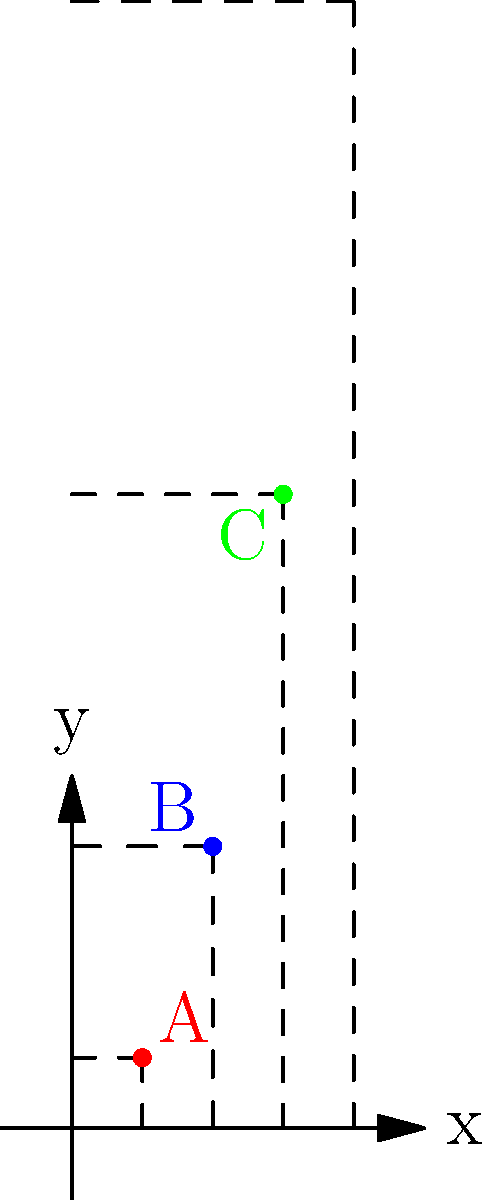In your GPS data visualization project, you've decided to use a unique coordinate transformation to represent user locations on a map. The transformation is defined as $(x, y) \rightarrow (x, f(x))$, where $f(x) = x^2$. If three users are located at points A(1, 1), B(2, 4), and C(3, 9) in the transformed coordinate system, what would be the y-coordinate of user C in the original, untransformed coordinate system? To solve this problem, we need to follow these steps:

1) The given transformation is $(x, y) \rightarrow (x, f(x))$, where $f(x) = x^2$.

2) We need to find the inverse transformation to go from the transformed coordinates back to the original coordinates.

3) The inverse of $f(x) = x^2$ is $f^{-1}(y) = \sqrt{y}$.

4) User C's coordinates in the transformed system are (3, 9).

5) The x-coordinate remains the same in both systems, so we only need to transform the y-coordinate.

6) Apply the inverse transformation to the y-coordinate:
   $y_{original} = f^{-1}(y_{transformed}) = \sqrt{y_{transformed}} = \sqrt{9} = 3$

Therefore, in the original coordinate system, user C's y-coordinate would be 3.
Answer: 3 